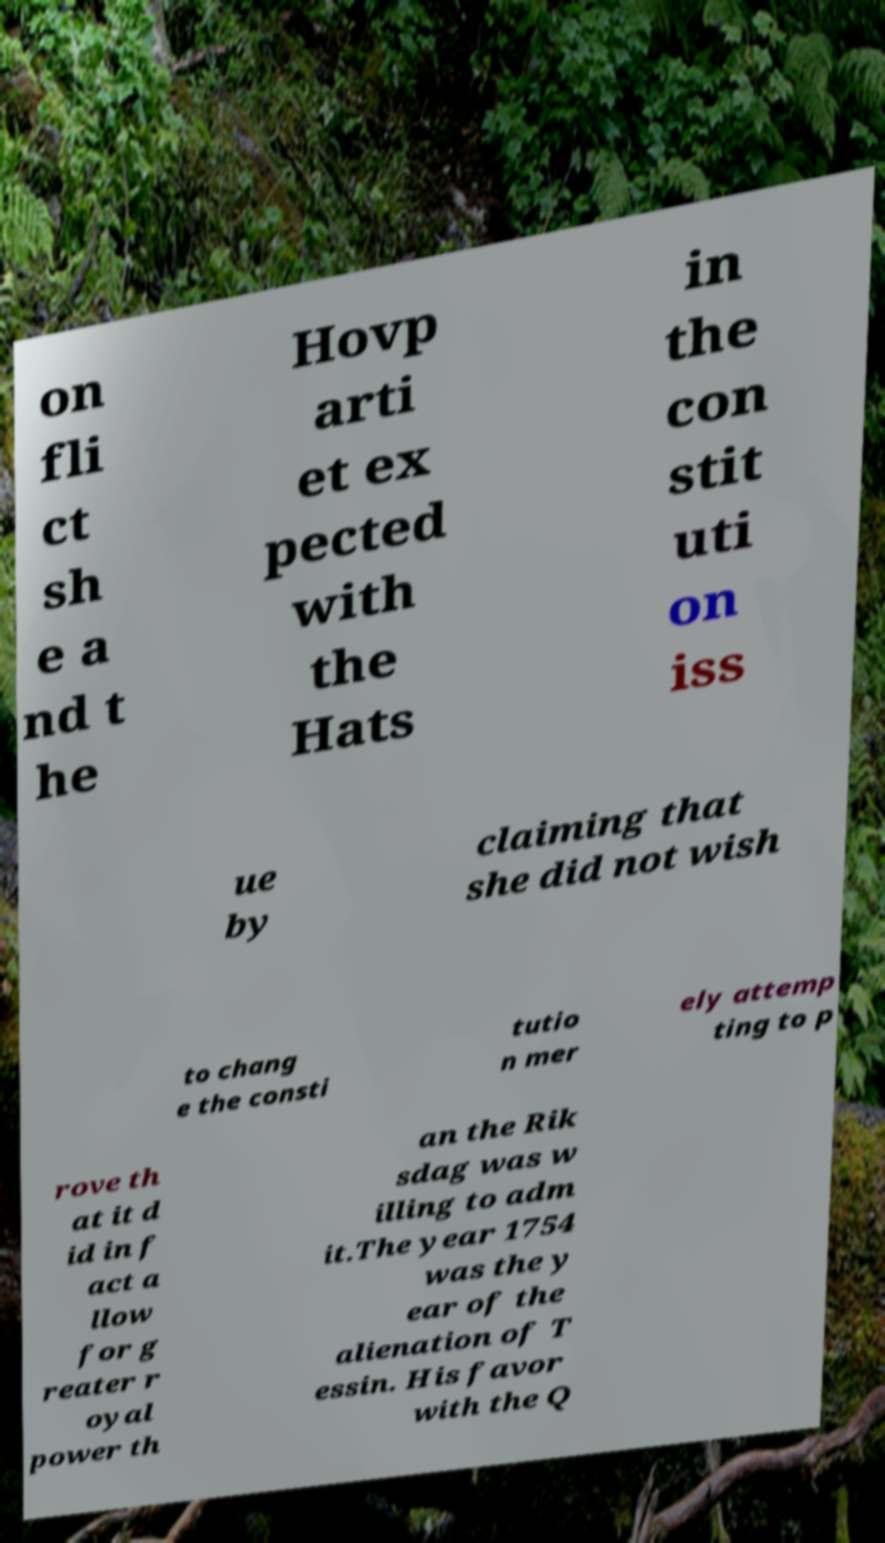What messages or text are displayed in this image? I need them in a readable, typed format. on fli ct sh e a nd t he Hovp arti et ex pected with the Hats in the con stit uti on iss ue by claiming that she did not wish to chang e the consti tutio n mer ely attemp ting to p rove th at it d id in f act a llow for g reater r oyal power th an the Rik sdag was w illing to adm it.The year 1754 was the y ear of the alienation of T essin. His favor with the Q 